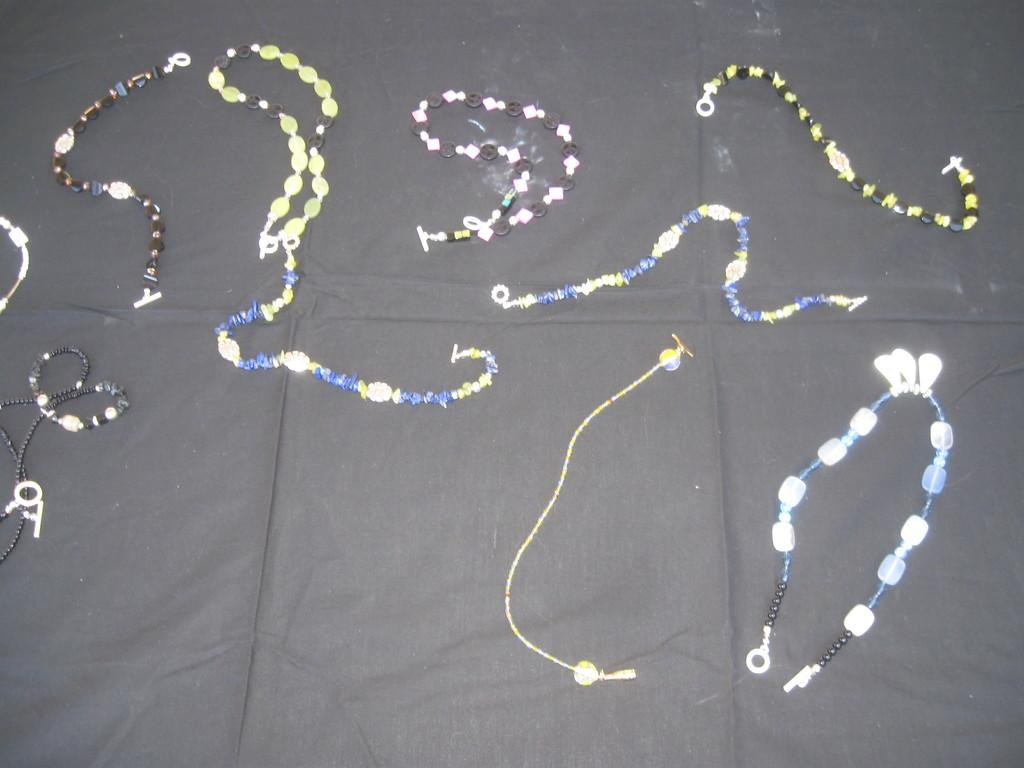What type of jewelry is visible in the image? There are bracelets in the image. How many different types of bracelets can be seen? There are many varieties of bracelets in the image. Where are the bracelets placed in the image? The bracelets are on a cloth. What type of zebra is visible in the image? There is no zebra present in the image; it features bracelets on a cloth. What type of thing is being used to hold the bracelets in the image? The image does not show a specific thing being used to hold the bracelets; they are simply placed on a cloth. 